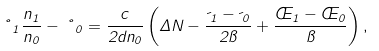<formula> <loc_0><loc_0><loc_500><loc_500>\nu _ { 1 } \frac { n _ { 1 } } { n _ { 0 } } - \nu _ { 0 } = \frac { c } { 2 d n _ { 0 } } \left ( \Delta N - \frac { \psi _ { 1 } - \psi _ { 0 } } { 2 \pi } + \frac { \phi _ { 1 } - \phi _ { 0 } } { \pi } \right ) ,</formula> 